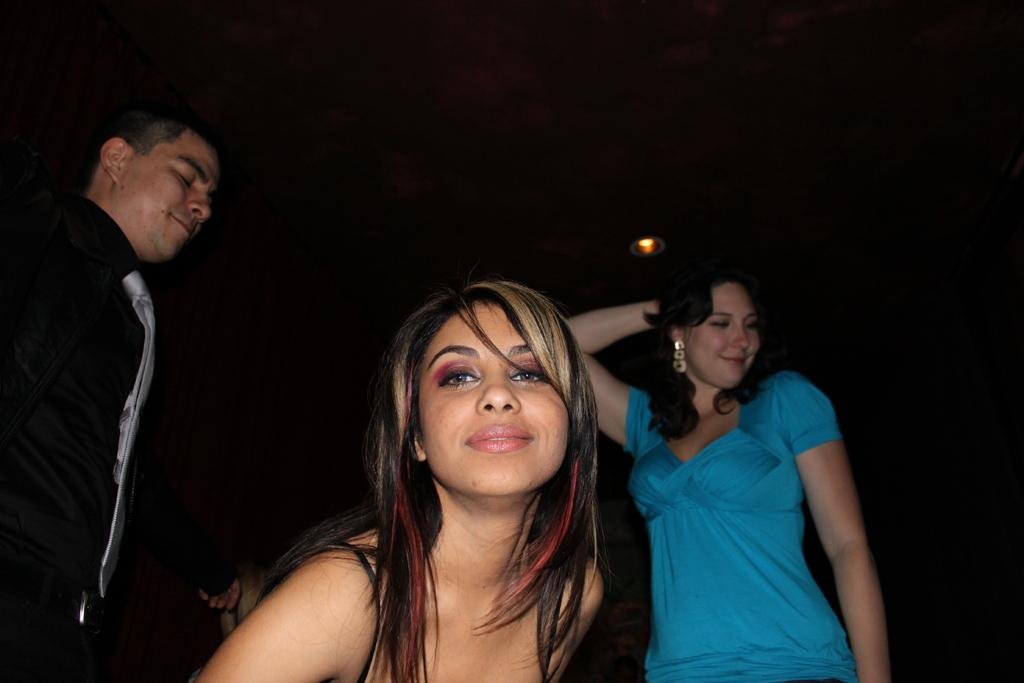How many people are in the image? There are three people in the image. What can be observed about the clothing of the people in the image? The people are wearing different color dresses. What is the color of the background in the image? The background of the image is black. Can you describe the lighting in the image? There is light visible in the image. What language are the people speaking in the image? The image does not provide any information about the language being spoken by the people. Can you see a kitten playing with the people in the image? There is no kitten present in the image. 